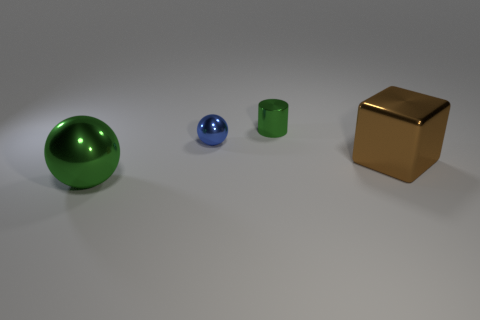There is a thing that is the same size as the shiny block; what is its color?
Your response must be concise. Green. The green thing that is the same shape as the blue shiny thing is what size?
Your answer should be very brief. Large. There is a green shiny object behind the metal cube; what is its shape?
Your answer should be very brief. Cylinder. There is a brown metallic thing; is its shape the same as the green metal thing right of the large metal ball?
Your answer should be very brief. No. Are there the same number of big green things that are on the right side of the large sphere and big things in front of the small metallic cylinder?
Make the answer very short. No. There is a tiny metal thing that is the same color as the big metallic sphere; what is its shape?
Provide a succinct answer. Cylinder. There is a large thing that is on the left side of the small metal cylinder; is its color the same as the cylinder behind the big green metallic ball?
Give a very brief answer. Yes. Are there more metal balls that are on the left side of the big metallic cube than small cyan matte balls?
Keep it short and to the point. Yes. What is the material of the green ball?
Give a very brief answer. Metal. The brown thing that is the same material as the small green object is what shape?
Keep it short and to the point. Cube. 